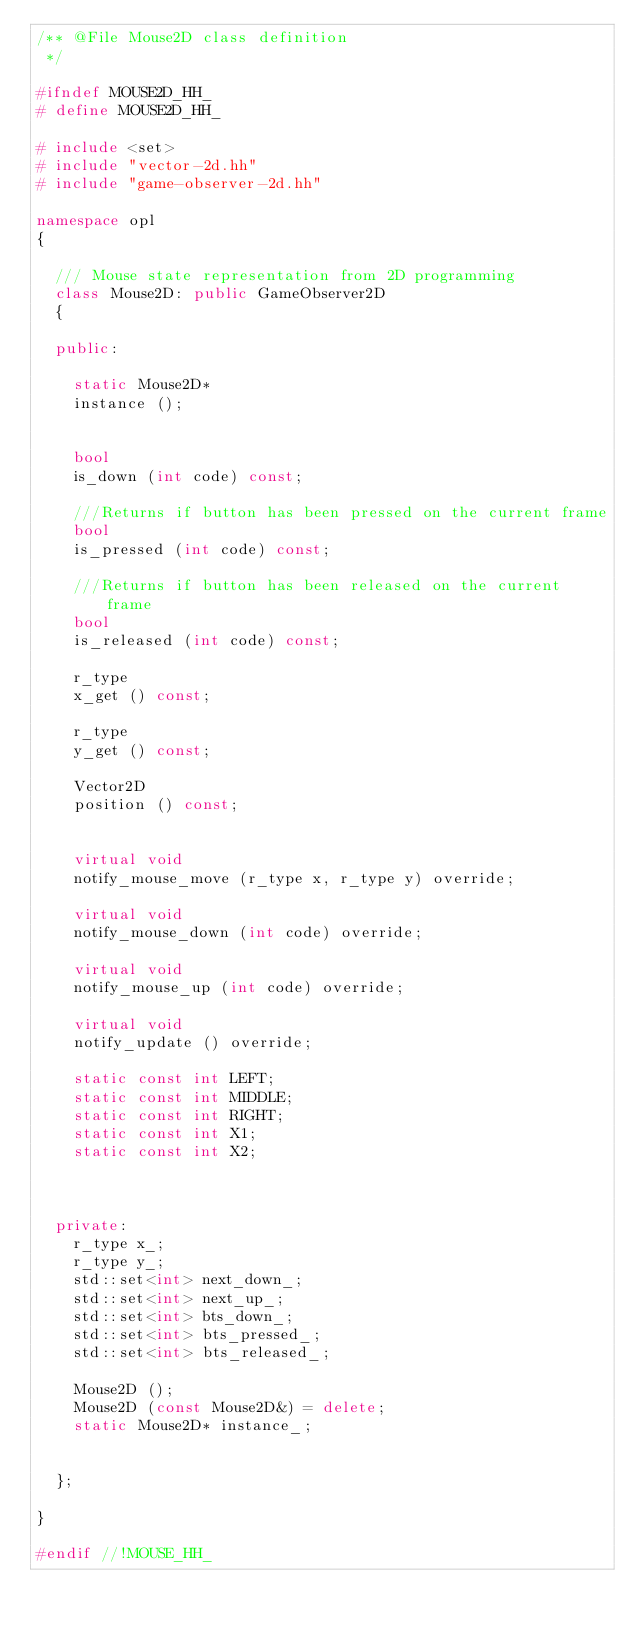<code> <loc_0><loc_0><loc_500><loc_500><_C++_>/** @File Mouse2D class definition
 */

#ifndef MOUSE2D_HH_
# define MOUSE2D_HH_

# include <set>
# include "vector-2d.hh"
# include "game-observer-2d.hh"

namespace opl
{

	/// Mouse state representation from 2D programming
	class Mouse2D: public GameObserver2D
	{

	public:

		static Mouse2D*
		instance ();


		bool
		is_down (int code) const;

		///Returns if button has been pressed on the current frame
		bool
		is_pressed (int code) const;

		///Returns if button has been released on the current frame
		bool
		is_released (int code) const;

		r_type
		x_get () const;

		r_type
		y_get () const;

		Vector2D
		position () const;


		virtual void
		notify_mouse_move (r_type x, r_type y) override;

		virtual void
		notify_mouse_down (int code) override;

		virtual void
		notify_mouse_up (int code) override;

		virtual void
		notify_update () override;

		static const int LEFT;
		static const int MIDDLE;
		static const int RIGHT;
		static const int X1;
		static const int X2;



	private:
		r_type x_;
		r_type y_;
		std::set<int> next_down_;
		std::set<int> next_up_;
		std::set<int> bts_down_;
		std::set<int> bts_pressed_;
		std::set<int> bts_released_;

		Mouse2D ();
		Mouse2D (const Mouse2D&) = delete;
		static Mouse2D* instance_;


	};

}

#endif //!MOUSE_HH_</code> 